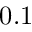<formula> <loc_0><loc_0><loc_500><loc_500>0 . 1</formula> 